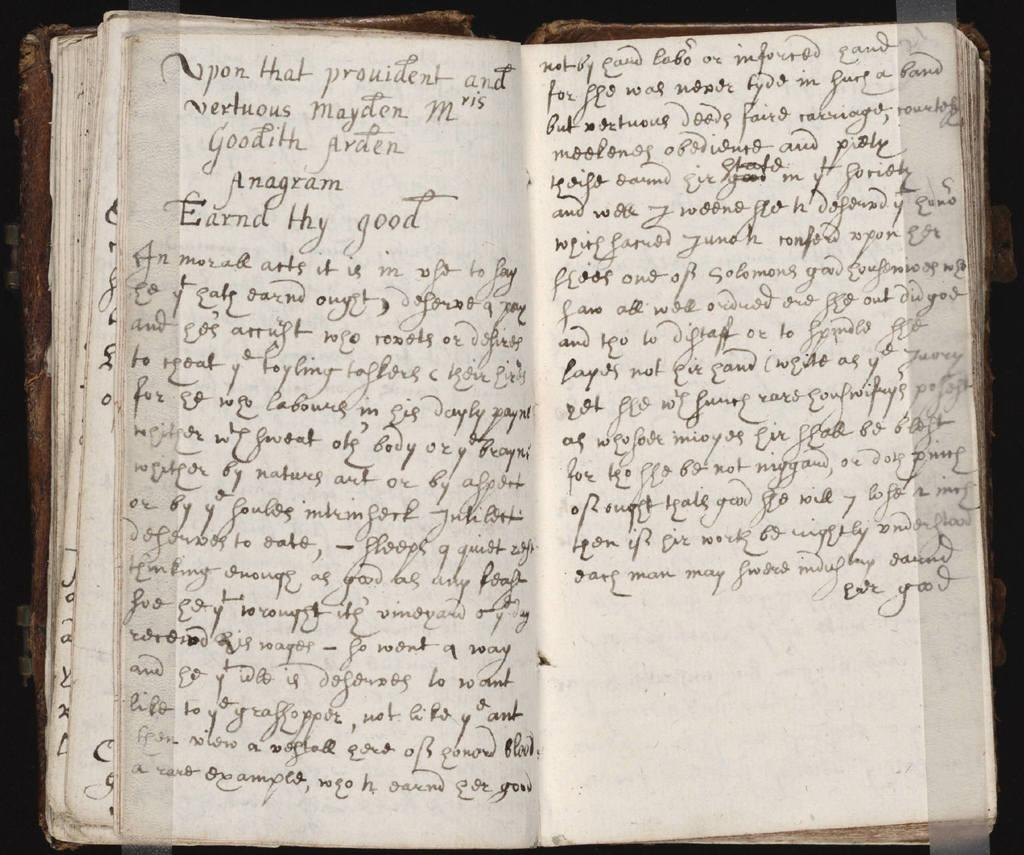Provide a one-sentence caption for the provided image. A book open to two pages of handwritten words that starts with, "Upon that Provident...". 